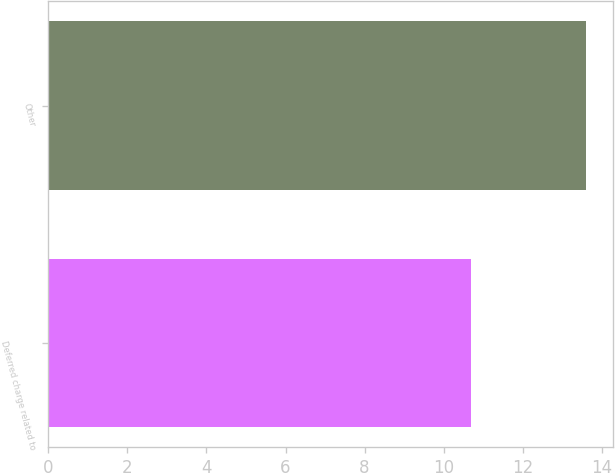Convert chart to OTSL. <chart><loc_0><loc_0><loc_500><loc_500><bar_chart><fcel>Deferred charge related to<fcel>Other<nl><fcel>10.7<fcel>13.6<nl></chart> 